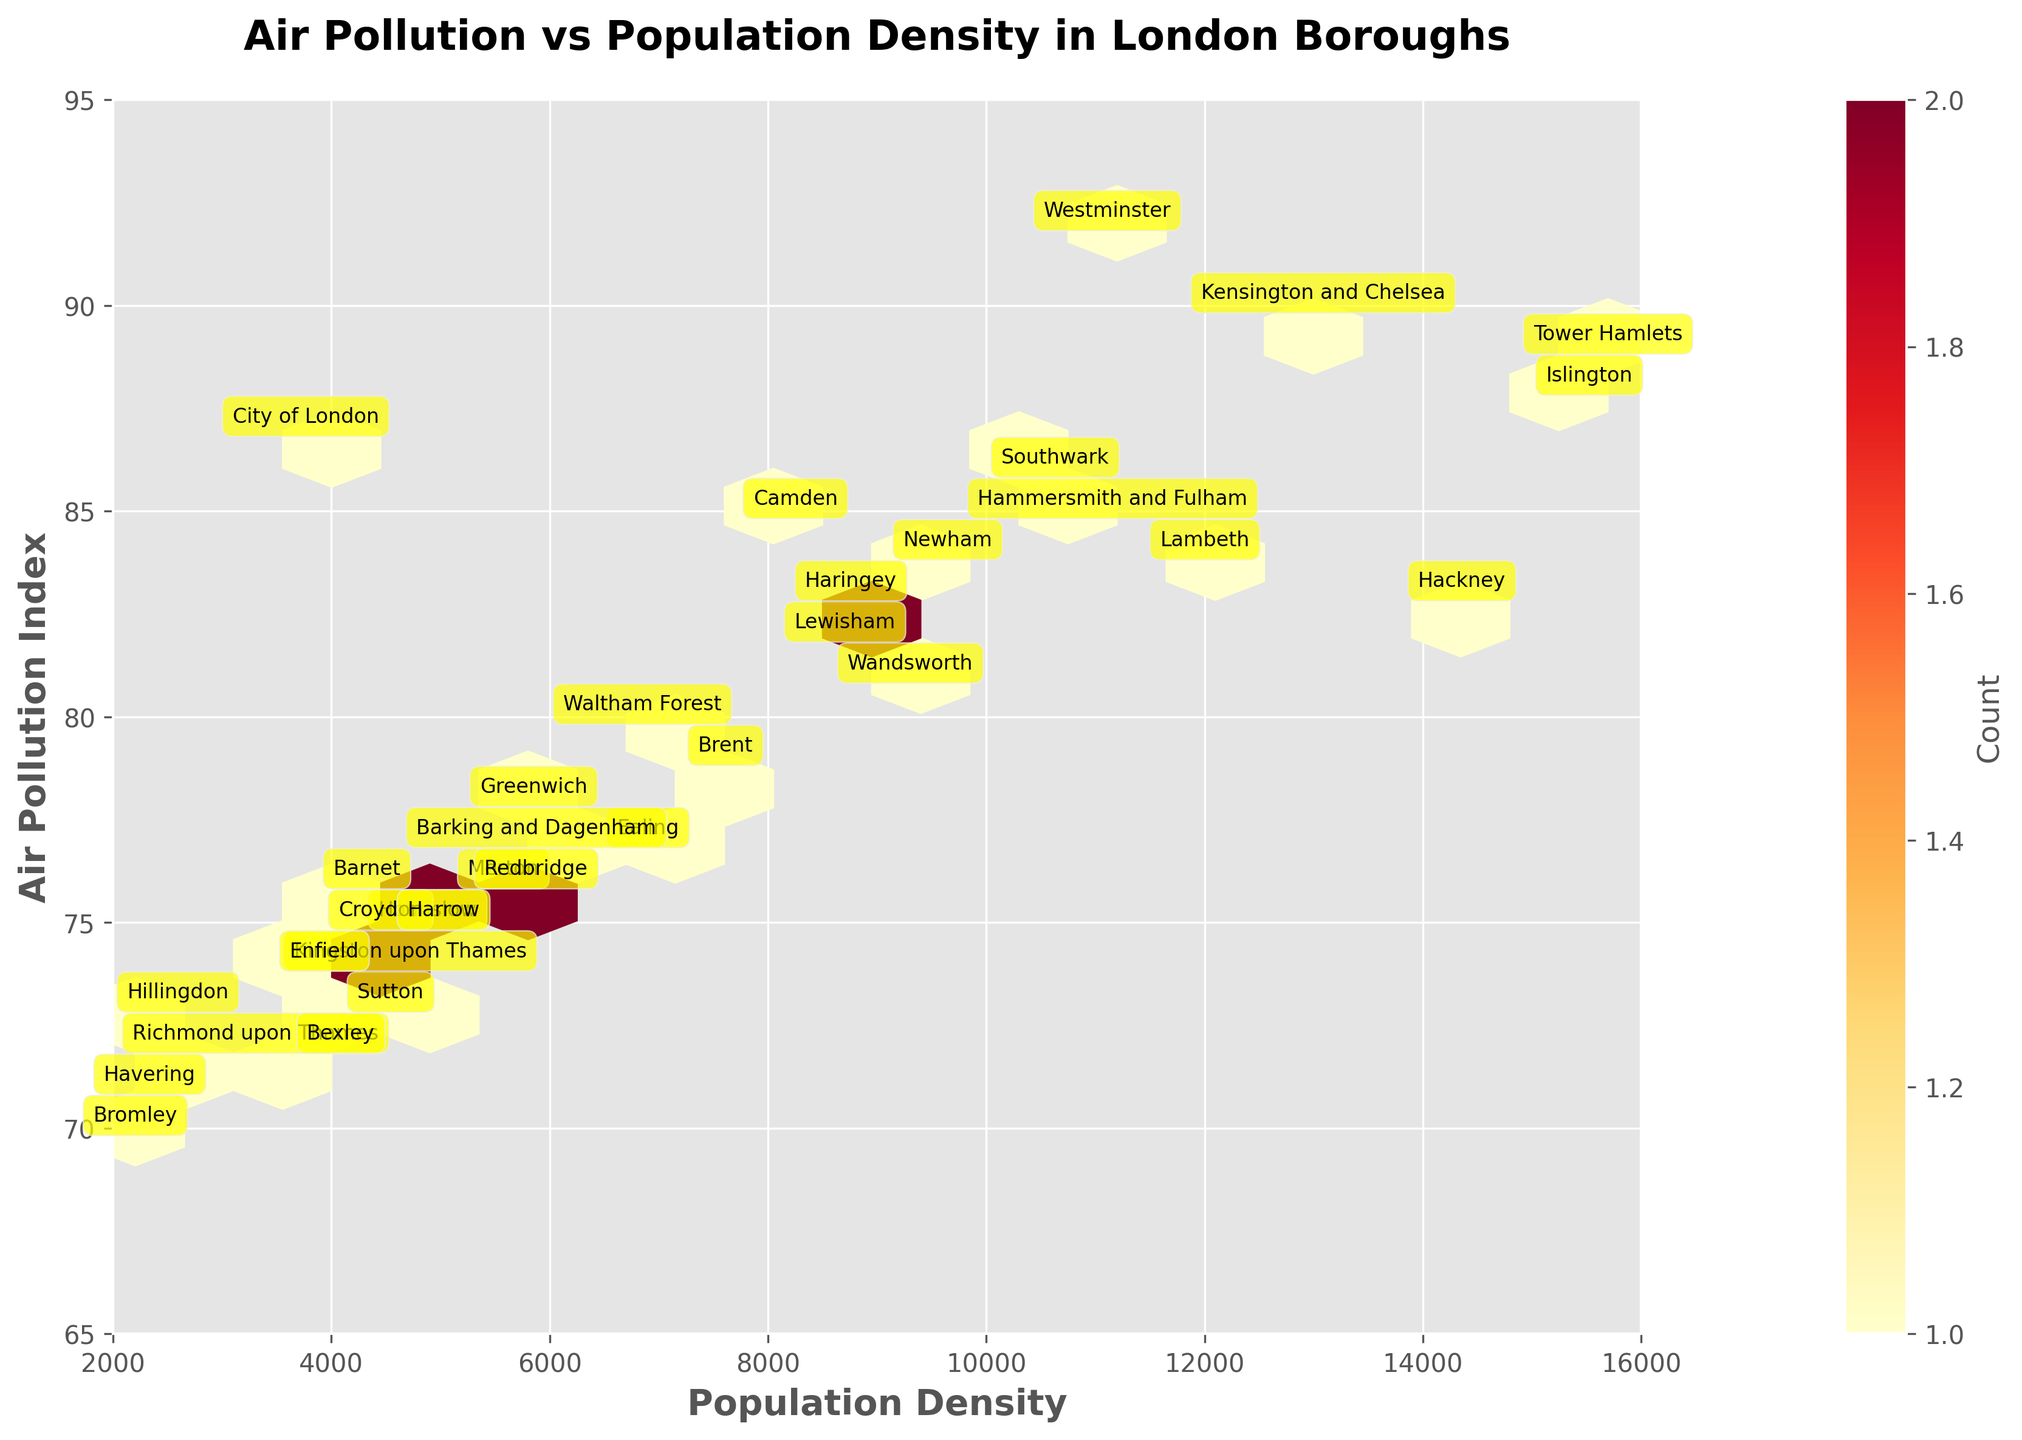which borough has the highest population density? The highest population density can be found by looking for the borough located furthest to the right on the horizontal axis.
Answer: Tower Hamlets What is the title of the plot? The title of the plot is the text displayed at the top.
Answer: Air Pollution vs Population Density in London Boroughs How many boroughs have an air pollution index greater than 90? Count the number of hexagons where the air pollution index is greater than 90 on the vertical axis.
Answer: 2 What is the air pollution index for the City of London? Find the City of London label and read its corresponding position on the vertical axis.
Answer: 87 Which borough has the lowest air pollution index? The lowest air pollution index corresponds to the borough positioned at the bottom of the plot on the vertical axis.
Answer: Bromley Are there more boroughs with an air pollution index above 80 or below 80? Count the number of boroughs above and below the value of 80 on the vertical axis and compare.
Answer: Above 80 What is the relationship between population density and air pollution index in the plot? Observe the general trend indicated by the distribution of hexagons. Higher population densities tend to cluster with higher air pollution indices, suggesting a positive correlation.
Answer: Positive correlation Which borough has a population density close to 10,000 and an air pollution index close to 85? Look for the boroughs near the coordinates where the population density is around 10,000 on the horizontal axis and the air pollution index is around 85 on the vertical axis.
Answer: Southwark Is there a borough with both low population density and high air pollution index? Check if any borough located on the left side of the horizontal axis has a high position on the vertical axis.
Answer: No 